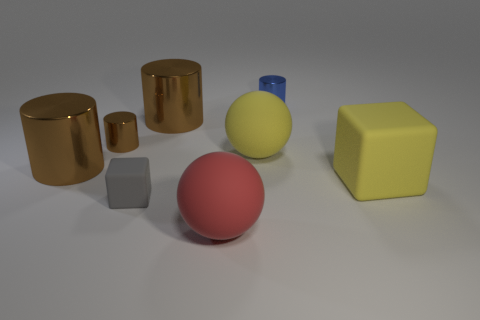How many brown cylinders must be subtracted to get 1 brown cylinders? 2 Subtract all purple spheres. How many brown cylinders are left? 3 Add 1 matte spheres. How many objects exist? 9 Subtract all blocks. How many objects are left? 6 Subtract all brown spheres. Subtract all tiny gray cubes. How many objects are left? 7 Add 3 spheres. How many spheres are left? 5 Add 8 small red matte blocks. How many small red matte blocks exist? 8 Subtract 0 cyan balls. How many objects are left? 8 